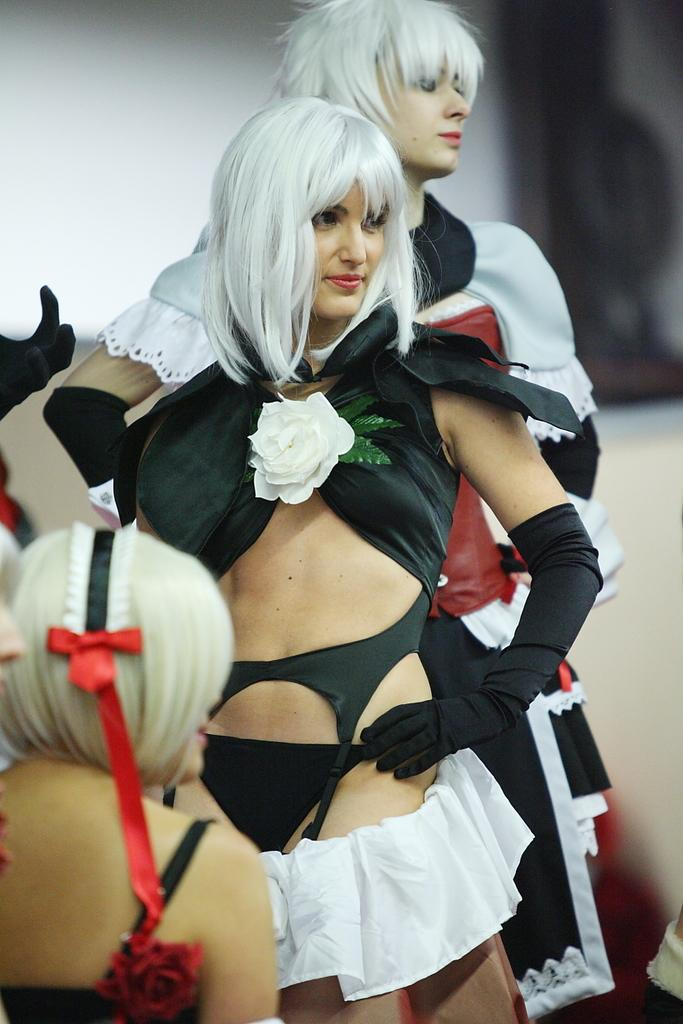Who is present in the image? There are people in the image. What are the people wearing? The people are wearing black and white dresses. How many people are standing in the image? Two people are standing. How many people are sitting in the image? One person is sitting. Can you describe the background of the image? The background is blurred. What type of wall is being used to paste the dresses in the image? There is no wall or paste present in the image; the people are wearing the black and white dresses. 